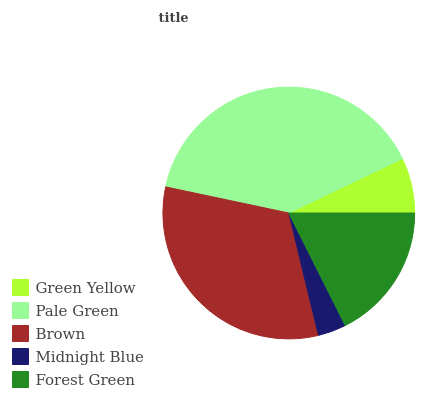Is Midnight Blue the minimum?
Answer yes or no. Yes. Is Pale Green the maximum?
Answer yes or no. Yes. Is Brown the minimum?
Answer yes or no. No. Is Brown the maximum?
Answer yes or no. No. Is Pale Green greater than Brown?
Answer yes or no. Yes. Is Brown less than Pale Green?
Answer yes or no. Yes. Is Brown greater than Pale Green?
Answer yes or no. No. Is Pale Green less than Brown?
Answer yes or no. No. Is Forest Green the high median?
Answer yes or no. Yes. Is Forest Green the low median?
Answer yes or no. Yes. Is Midnight Blue the high median?
Answer yes or no. No. Is Pale Green the low median?
Answer yes or no. No. 